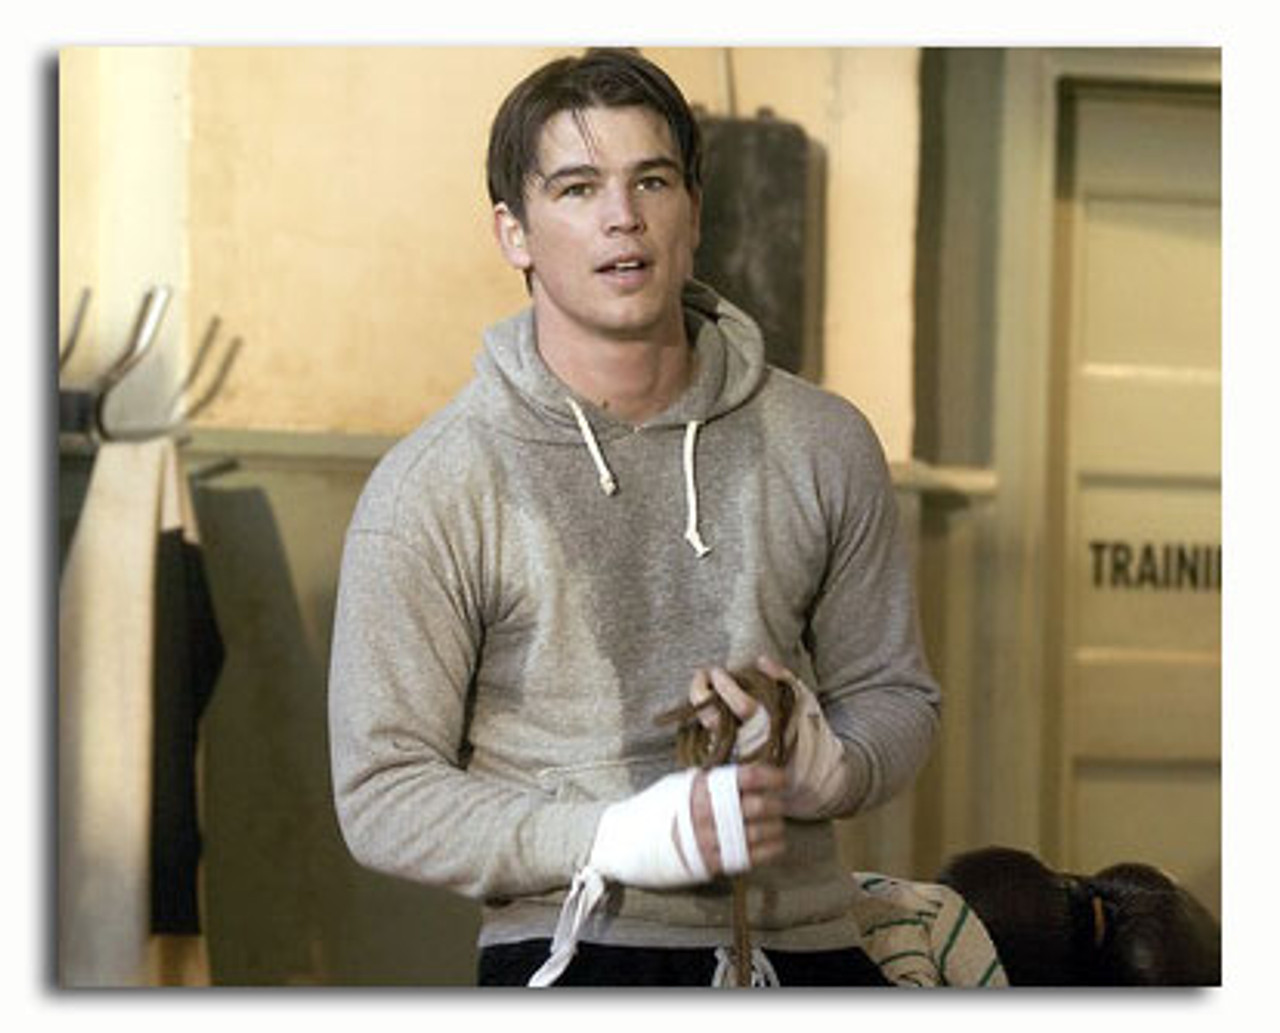Analyze the image in a comprehensive and detailed manner. The image showcases a man in a gray hoodie, standing in a gym setting. He appears to be preparing for or taking a break from a physical activity, evident from the bandages around his wrists commonly used in boxing. The location seems to be a boxing gym, as suggested by the blurred punching bag in the background. His relaxed yet focused demeanour may suggest he's either strategizing his next move or reflecting on his performance. The lighting is subdued, creating a calm yet intense atmosphere typical of training environments. 